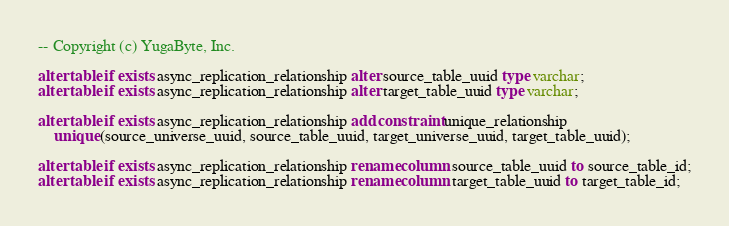<code> <loc_0><loc_0><loc_500><loc_500><_SQL_>-- Copyright (c) YugaByte, Inc.

alter table if exists async_replication_relationship alter source_table_uuid type varchar;
alter table if exists async_replication_relationship alter target_table_uuid type varchar;

alter table if exists async_replication_relationship add constraint unique_relationship
    unique (source_universe_uuid, source_table_uuid, target_universe_uuid, target_table_uuid);

alter table if exists async_replication_relationship rename column source_table_uuid to source_table_id;
alter table if exists async_replication_relationship rename column target_table_uuid to target_table_id;
</code> 